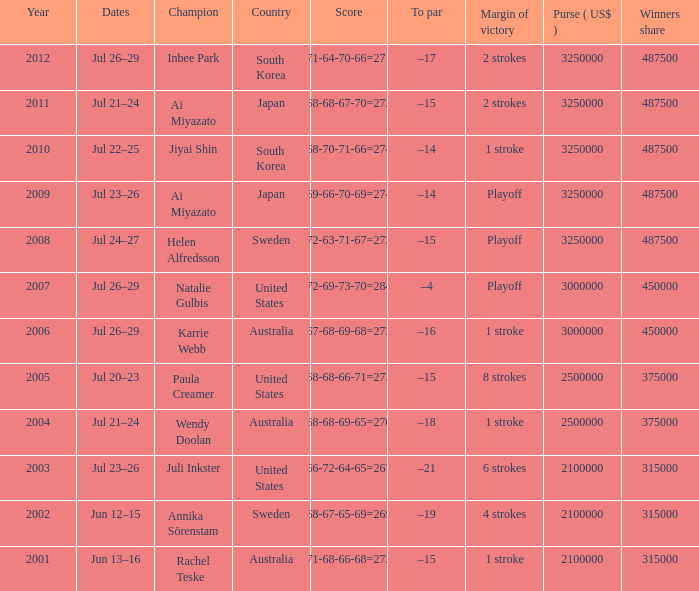In what countries can a 6-stroke margin of victory be observed? United States. I'm looking to parse the entire table for insights. Could you assist me with that? {'header': ['Year', 'Dates', 'Champion', 'Country', 'Score', 'To par', 'Margin of victory', 'Purse ( US$ )', 'Winners share'], 'rows': [['2012', 'Jul 26–29', 'Inbee Park', 'South Korea', '71-64-70-66=271', '–17', '2 strokes', '3250000', '487500'], ['2011', 'Jul 21–24', 'Ai Miyazato', 'Japan', '68-68-67-70=273', '–15', '2 strokes', '3250000', '487500'], ['2010', 'Jul 22–25', 'Jiyai Shin', 'South Korea', '68-70-71-66=274', '–14', '1 stroke', '3250000', '487500'], ['2009', 'Jul 23–26', 'Ai Miyazato', 'Japan', '69-66-70-69=274', '–14', 'Playoff', '3250000', '487500'], ['2008', 'Jul 24–27', 'Helen Alfredsson', 'Sweden', '72-63-71-67=273', '–15', 'Playoff', '3250000', '487500'], ['2007', 'Jul 26–29', 'Natalie Gulbis', 'United States', '72-69-73-70=284', '–4', 'Playoff', '3000000', '450000'], ['2006', 'Jul 26–29', 'Karrie Webb', 'Australia', '67-68-69-68=272', '–16', '1 stroke', '3000000', '450000'], ['2005', 'Jul 20–23', 'Paula Creamer', 'United States', '68-68-66-71=273', '–15', '8 strokes', '2500000', '375000'], ['2004', 'Jul 21–24', 'Wendy Doolan', 'Australia', '68-68-69-65=270', '–18', '1 stroke', '2500000', '375000'], ['2003', 'Jul 23–26', 'Juli Inkster', 'United States', '66-72-64-65=267', '–21', '6 strokes', '2100000', '315000'], ['2002', 'Jun 12–15', 'Annika Sörenstam', 'Sweden', '68-67-65-69=269', '–19', '4 strokes', '2100000', '315000'], ['2001', 'Jun 13–16', 'Rachel Teske', 'Australia', '71-68-66-68=273', '–15', '1 stroke', '2100000', '315000']]} 